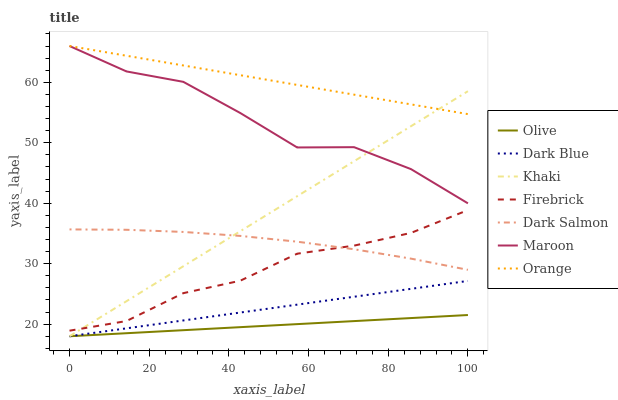Does Olive have the minimum area under the curve?
Answer yes or no. Yes. Does Orange have the maximum area under the curve?
Answer yes or no. Yes. Does Firebrick have the minimum area under the curve?
Answer yes or no. No. Does Firebrick have the maximum area under the curve?
Answer yes or no. No. Is Olive the smoothest?
Answer yes or no. Yes. Is Maroon the roughest?
Answer yes or no. Yes. Is Firebrick the smoothest?
Answer yes or no. No. Is Firebrick the roughest?
Answer yes or no. No. Does Khaki have the lowest value?
Answer yes or no. Yes. Does Firebrick have the lowest value?
Answer yes or no. No. Does Orange have the highest value?
Answer yes or no. Yes. Does Firebrick have the highest value?
Answer yes or no. No. Is Firebrick less than Orange?
Answer yes or no. Yes. Is Firebrick greater than Olive?
Answer yes or no. Yes. Does Khaki intersect Dark Blue?
Answer yes or no. Yes. Is Khaki less than Dark Blue?
Answer yes or no. No. Is Khaki greater than Dark Blue?
Answer yes or no. No. Does Firebrick intersect Orange?
Answer yes or no. No. 